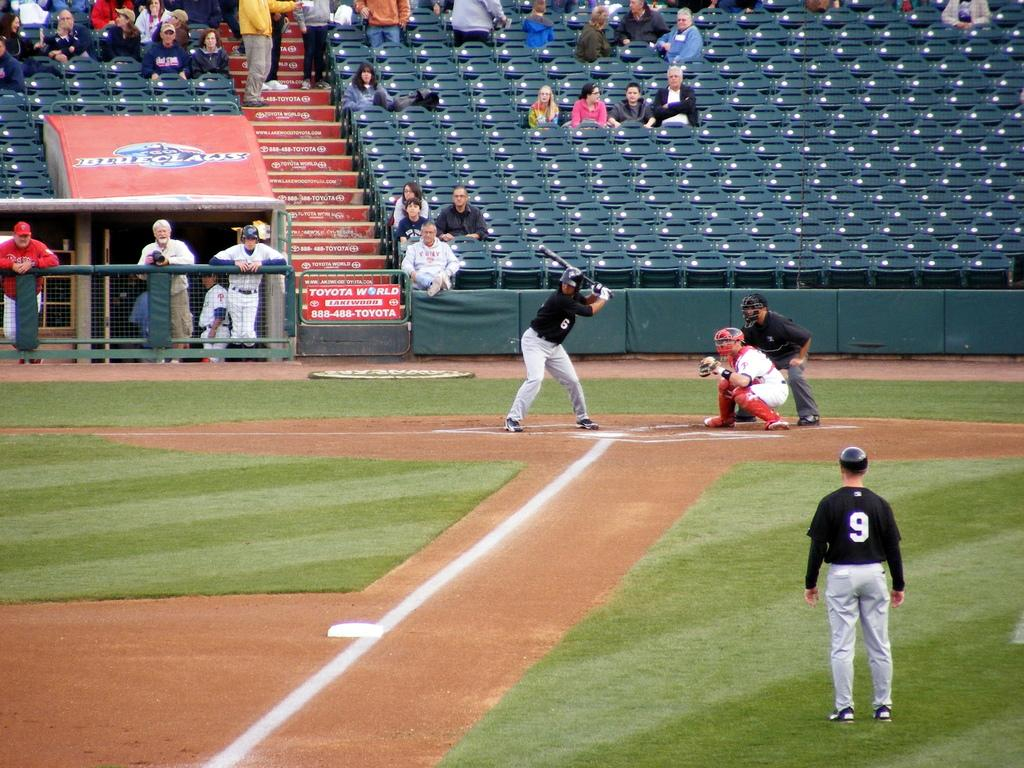Provide a one-sentence caption for the provided image. Daytime baseball game which is sponsored by Toyota World. 